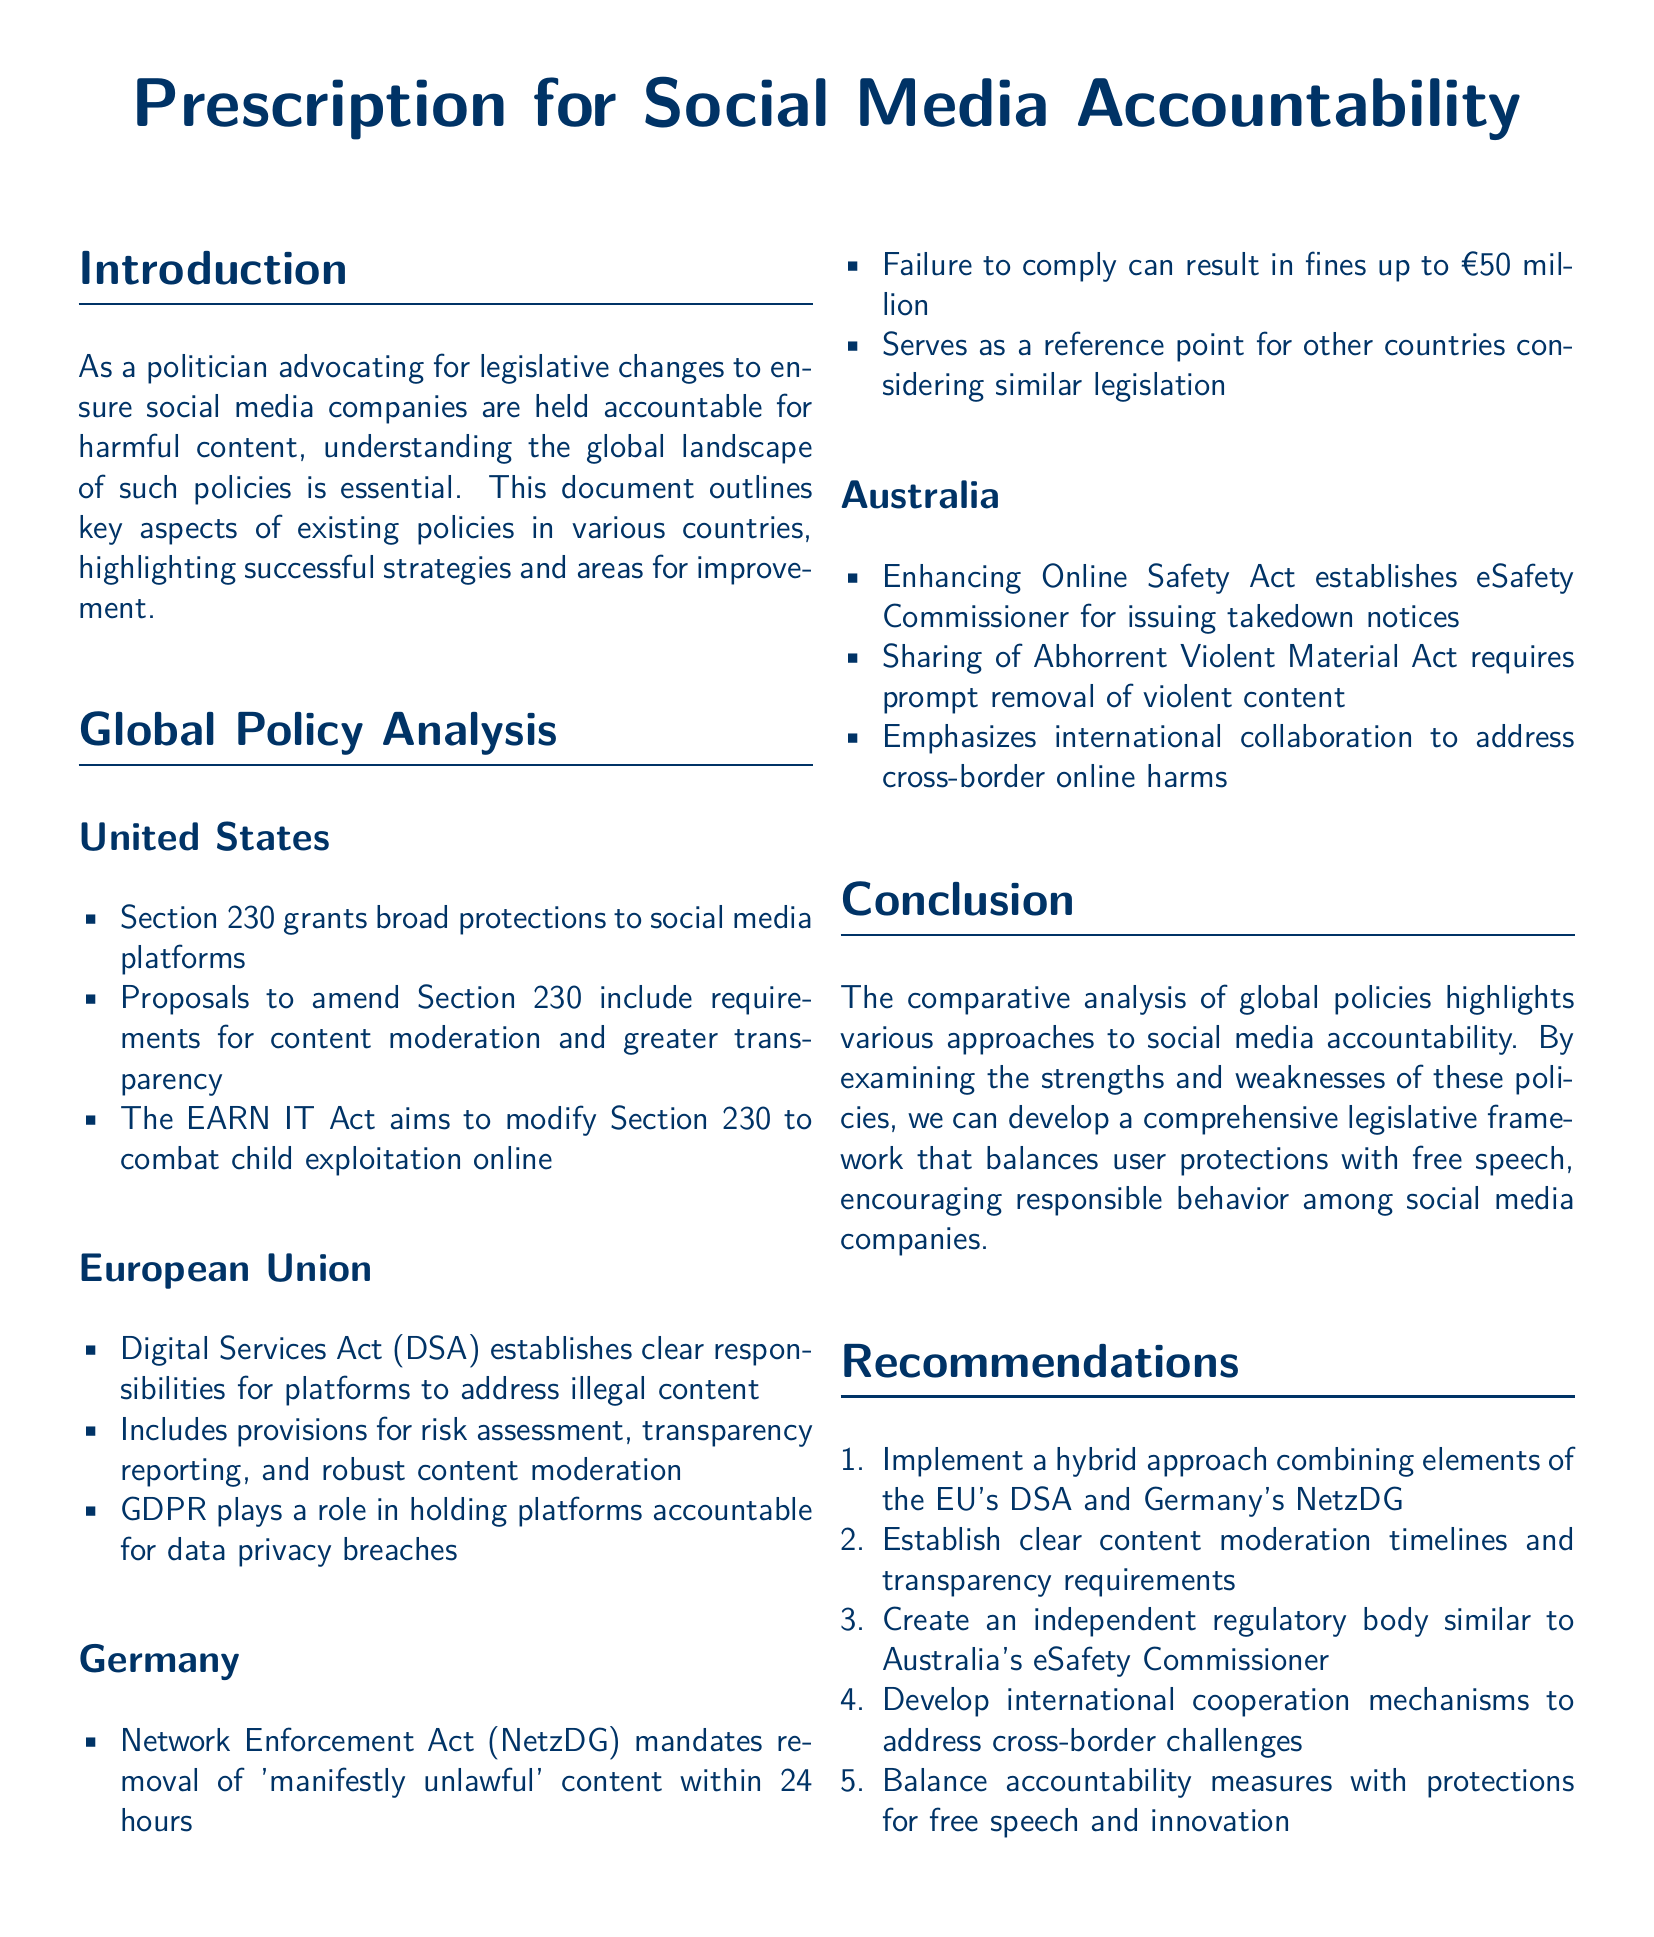What is the title of the document? The title is presented prominently at the beginning of the document.
Answer: Prescription for Social Media Accountability Which act aims to modify Section 230? The act is mentioned in the section discussing the United States' policies and its purpose is detailed.
Answer: EARN IT Act What is the fine for failing to comply with Germany's NetzDG? The potential penalty for non-compliance is stated in the Germany section.
Answer: €50 million What does the Digital Services Act establish? This is stated in the European Union section as a key aspect of the policy.
Answer: Clear responsibilities for platforms What is one of the recommendations for improving social media accountability? Recommendations are outlined in a specific section of the document, indicating proposed initiatives.
Answer: Implement a hybrid approach How many hours does Germany's NetzDG allow for content removal? This is specified in the Germany section regarding content moderation timelines.
Answer: 24 hours What role does the eSafety Commissioner serve in Australia? The role is described in the section about Australian policies and their focus.
Answer: Issuing takedown notices Which country has a legislative framework focusing on risk assessment and transparency reporting? This is detailed in the European Union section of global policy analysis.
Answer: European Union What does the Enhancing Online Safety Act aim to address? This is indicated in the Australian section and summarizes its primary focus.
Answer: Online safety 